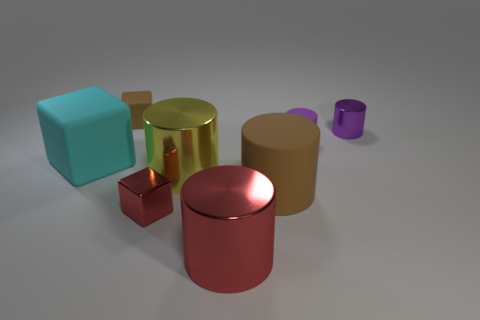Subtract all green blocks. How many purple cylinders are left? 2 Add 1 red objects. How many objects exist? 9 Subtract all cyan blocks. How many blocks are left? 2 Subtract all brown cylinders. How many cylinders are left? 4 Subtract 3 cylinders. How many cylinders are left? 2 Subtract all cubes. How many objects are left? 5 Subtract all gray blocks. Subtract all cyan spheres. How many blocks are left? 3 Subtract all large rubber objects. Subtract all tiny purple balls. How many objects are left? 6 Add 6 brown blocks. How many brown blocks are left? 7 Add 5 small cylinders. How many small cylinders exist? 7 